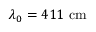Convert formula to latex. <formula><loc_0><loc_0><loc_500><loc_500>\lambda _ { 0 } = 4 1 1 \ c m</formula> 